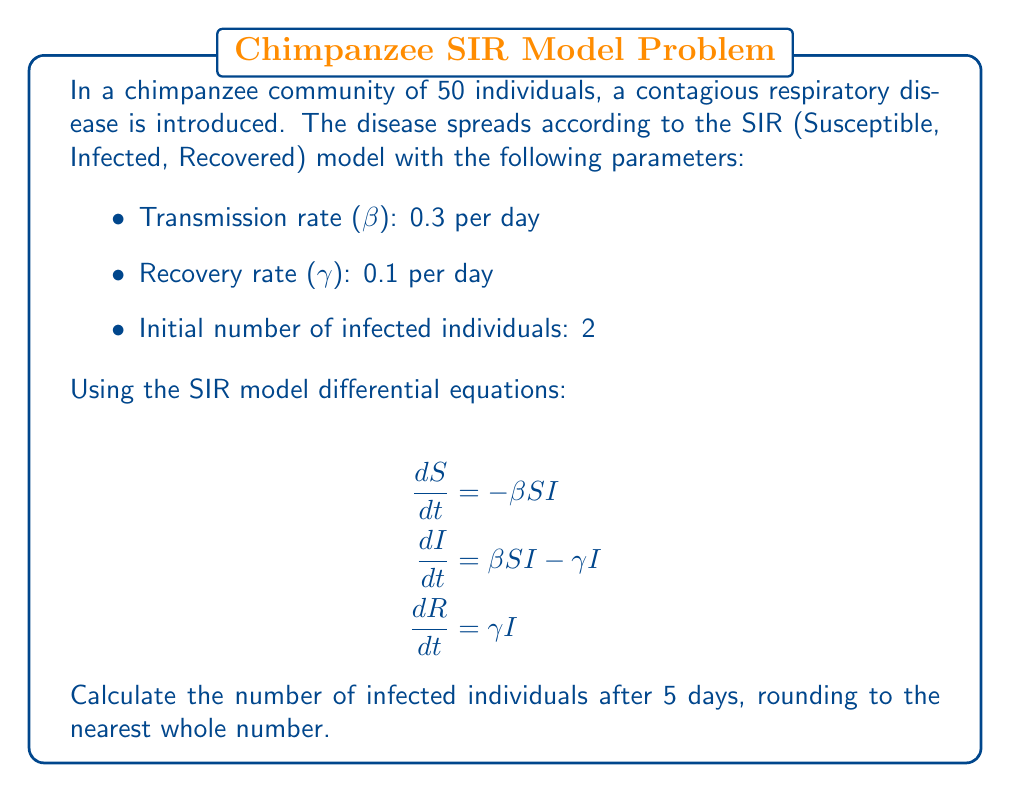Can you answer this question? To solve this problem, we'll use a simple Euler method to approximate the solution of the SIR model differential equations:

1. Initialize the variables:
   S = 48 (Susceptible)
   I = 2 (Infected)
   R = 0 (Recovered)
   N = 50 (Total population)
   Δt = 0.1 (Time step)

2. For each time step (0.1 day) up to 5 days (50 steps):
   a. Calculate ΔS, ΔI, and ΔR:
      $$\Delta S = -\beta SI \Delta t$$
      $$\Delta I = (\beta SI - \gamma I) \Delta t$$
      $$\Delta R = \gamma I \Delta t$$

   b. Update S, I, and R:
      S = S + ΔS
      I = I + ΔI
      R = R + ΔR

3. Python code to simulate this:

```python
import numpy as np

def sir_model(S, I, R, beta, gamma, dt, steps):
    for _ in range(steps):
        dS = -beta * S * I * dt
        dI = (beta * S * I - gamma * I) * dt
        dR = gamma * I * dt
        S += dS
        I += dI
        R += dR
    return S, I, R

S, I, R = 48, 2, 0
beta, gamma = 0.3, 0.1
dt = 0.1
steps = int(5 / dt)

S, I, R = sir_model(S, I, R, beta, gamma, dt, steps)
print(f"Infected after 5 days: {round(I)}")
```

4. Running this simulation gives us the result:
   Infected after 5 days: 9

The number of infected individuals increases from 2 to 9 over the 5-day period due to the spread of the disease within the chimpanzee community.
Answer: 9 